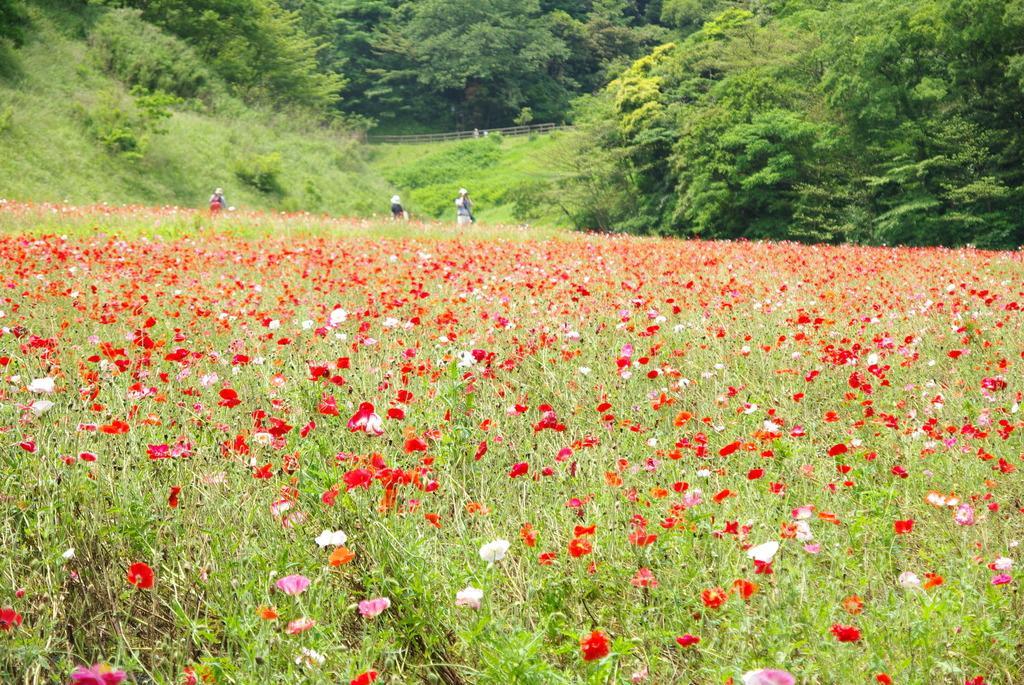Can you describe this image briefly? In this image, there is an outside view. In the foreground, we can see some plants contains flowers. In the background, there are some trees. 